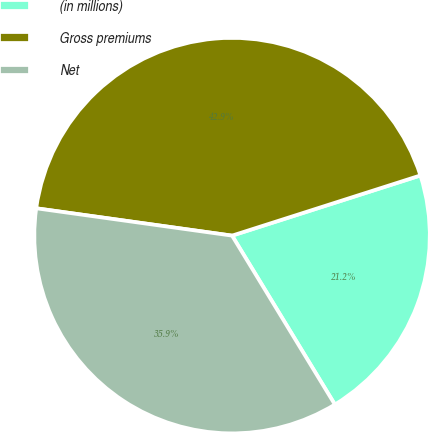<chart> <loc_0><loc_0><loc_500><loc_500><pie_chart><fcel>(in millions)<fcel>Gross premiums<fcel>Net<nl><fcel>21.22%<fcel>42.87%<fcel>35.91%<nl></chart> 